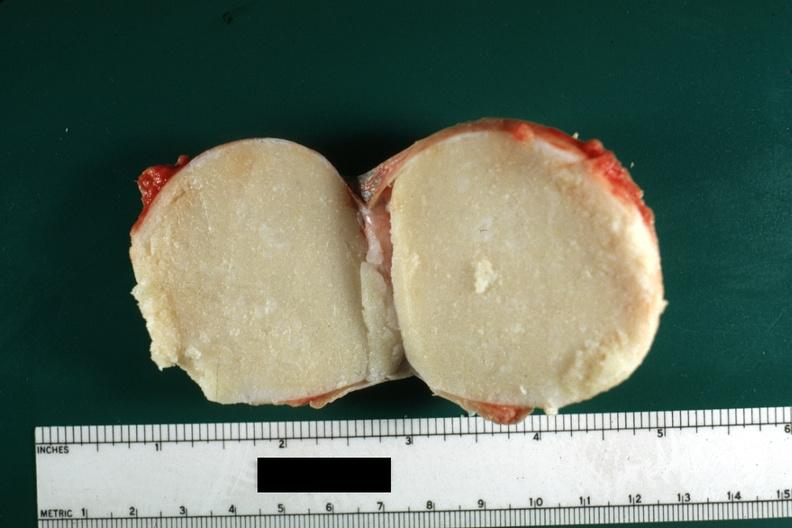what does this image show?
Answer the question using a single word or phrase. Cut surface typical cheese like yellow content and thin fibrous capsule lesion was from the scrotal skin 